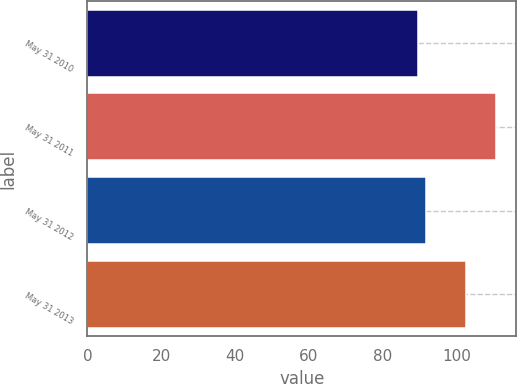<chart> <loc_0><loc_0><loc_500><loc_500><bar_chart><fcel>May 31 2010<fcel>May 31 2011<fcel>May 31 2012<fcel>May 31 2013<nl><fcel>89.7<fcel>110.67<fcel>91.8<fcel>102.51<nl></chart> 